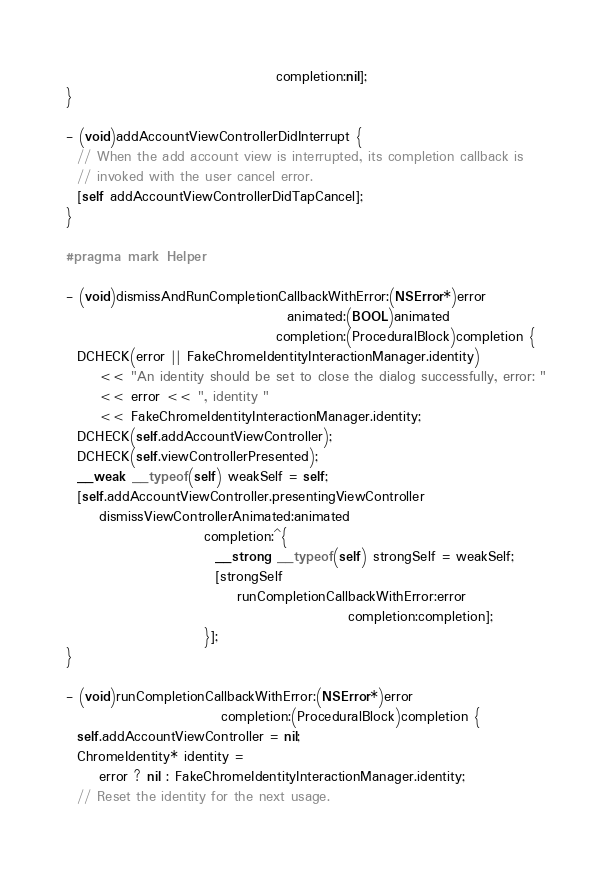Convert code to text. <code><loc_0><loc_0><loc_500><loc_500><_ObjectiveC_>                                      completion:nil];
}

- (void)addAccountViewControllerDidInterrupt {
  // When the add account view is interrupted, its completion callback is
  // invoked with the user cancel error.
  [self addAccountViewControllerDidTapCancel];
}

#pragma mark Helper

- (void)dismissAndRunCompletionCallbackWithError:(NSError*)error
                                        animated:(BOOL)animated
                                      completion:(ProceduralBlock)completion {
  DCHECK(error || FakeChromeIdentityInteractionManager.identity)
      << "An identity should be set to close the dialog successfully, error: "
      << error << ", identity "
      << FakeChromeIdentityInteractionManager.identity;
  DCHECK(self.addAccountViewController);
  DCHECK(self.viewControllerPresented);
  __weak __typeof(self) weakSelf = self;
  [self.addAccountViewController.presentingViewController
      dismissViewControllerAnimated:animated
                         completion:^{
                           __strong __typeof(self) strongSelf = weakSelf;
                           [strongSelf
                               runCompletionCallbackWithError:error
                                                   completion:completion];
                         }];
}

- (void)runCompletionCallbackWithError:(NSError*)error
                            completion:(ProceduralBlock)completion {
  self.addAccountViewController = nil;
  ChromeIdentity* identity =
      error ? nil : FakeChromeIdentityInteractionManager.identity;
  // Reset the identity for the next usage.</code> 